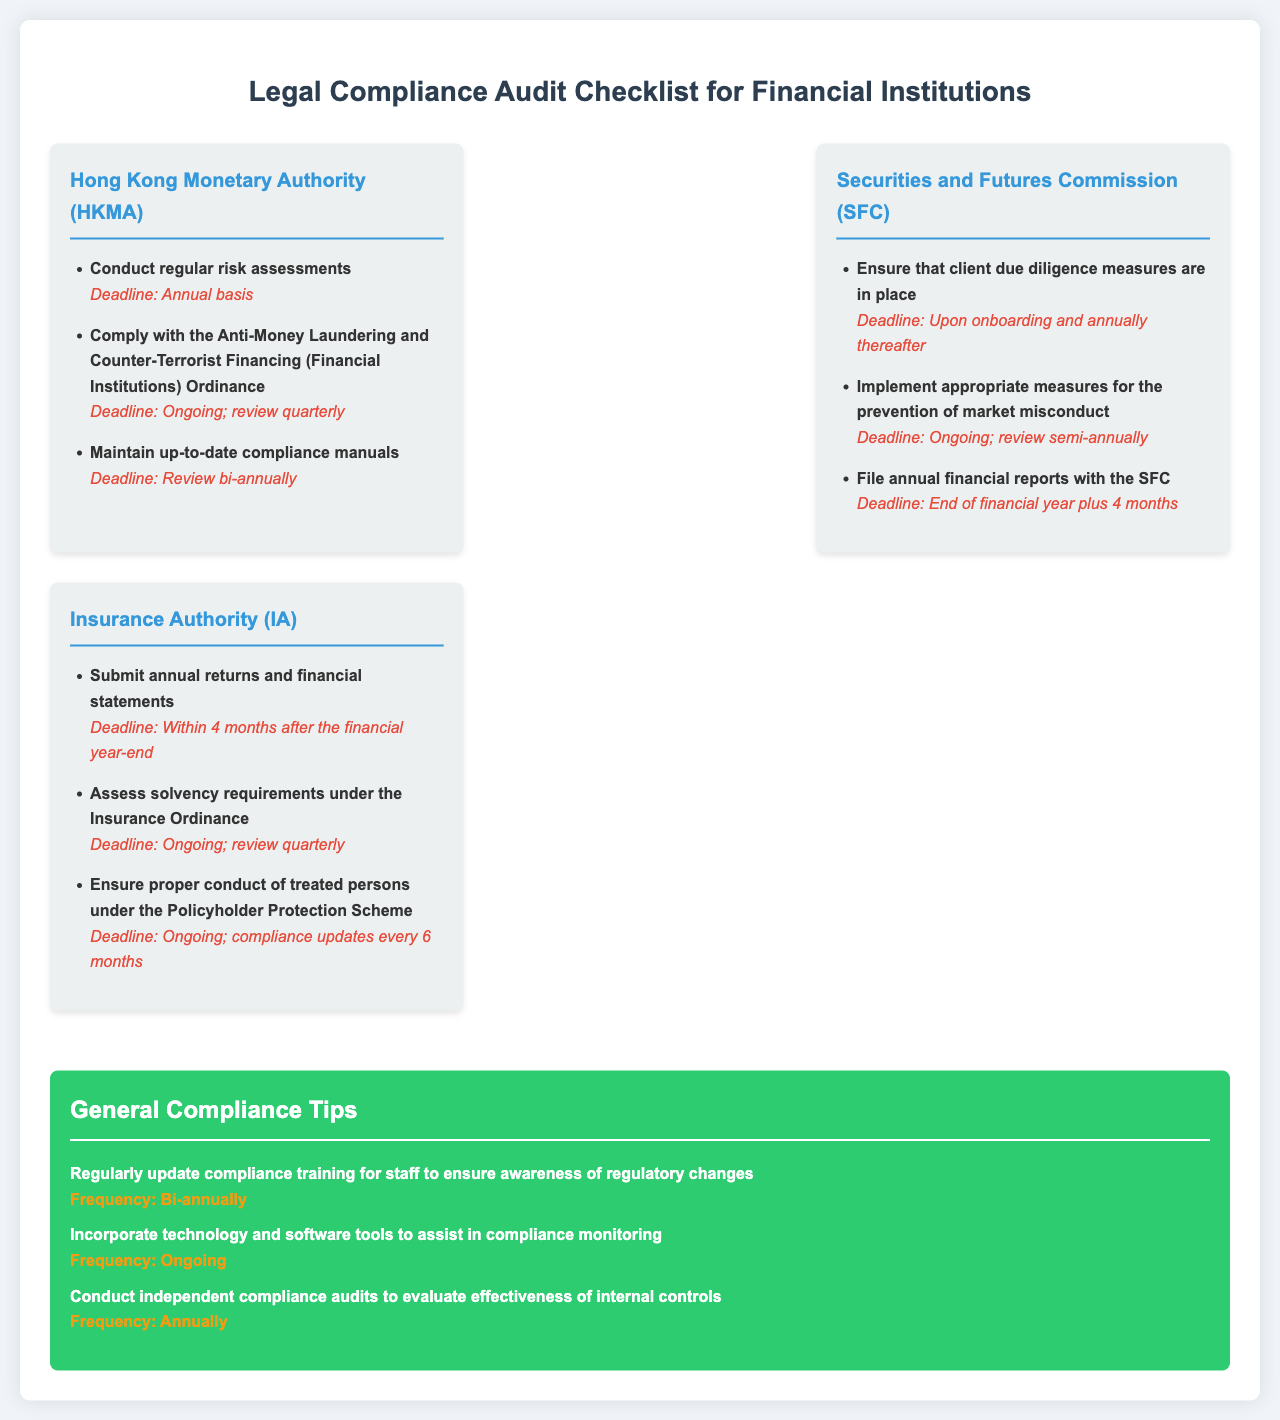what is the deadline for conducting regular risk assessments under HKMA? The deadline for conducting regular risk assessments under HKMA is mentioned as an annual basis in the document.
Answer: Annual basis what is the frequency for filing annual financial reports with the SFC? The frequency for filing annual financial reports with the SFC is specified as end of financial year plus four months.
Answer: End of financial year plus 4 months how often should compliance manuals be reviewed according to HKMA? The document states that compliance manuals should be reviewed bi-annually under HKMA regulations.
Answer: Review bi-annually what is the deadline for assessing solvency requirements under the Insurance Ordinance? It states that the assessment of solvency requirements is an ongoing process reviewed quarterly under the Insurance Authority.
Answer: Ongoing; review quarterly how frequently should compliance training for staff be updated? The document mentions that compliance training for staff should be updated bi-annually.
Answer: Bi-annually what is the deadline for submitting annual returns under the Insurance Authority? The deadline for submitting annual returns is within four months after the financial year-end as specified in the document.
Answer: Within 4 months after the financial year-end what is the recommended review frequency for measures to prevent market misconduct under SFC? It is indicated that measures to prevent market misconduct should be reviewed semi-annually in the document.
Answer: Review semi-annually how often should independent compliance audits be conducted? The frequency specified for conducting independent compliance audits is annually in the document.
Answer: Annually what type of tools are suggested for compliance monitoring? The document suggests incorporating technology and software tools to assist in compliance monitoring.
Answer: Technology and software tools 